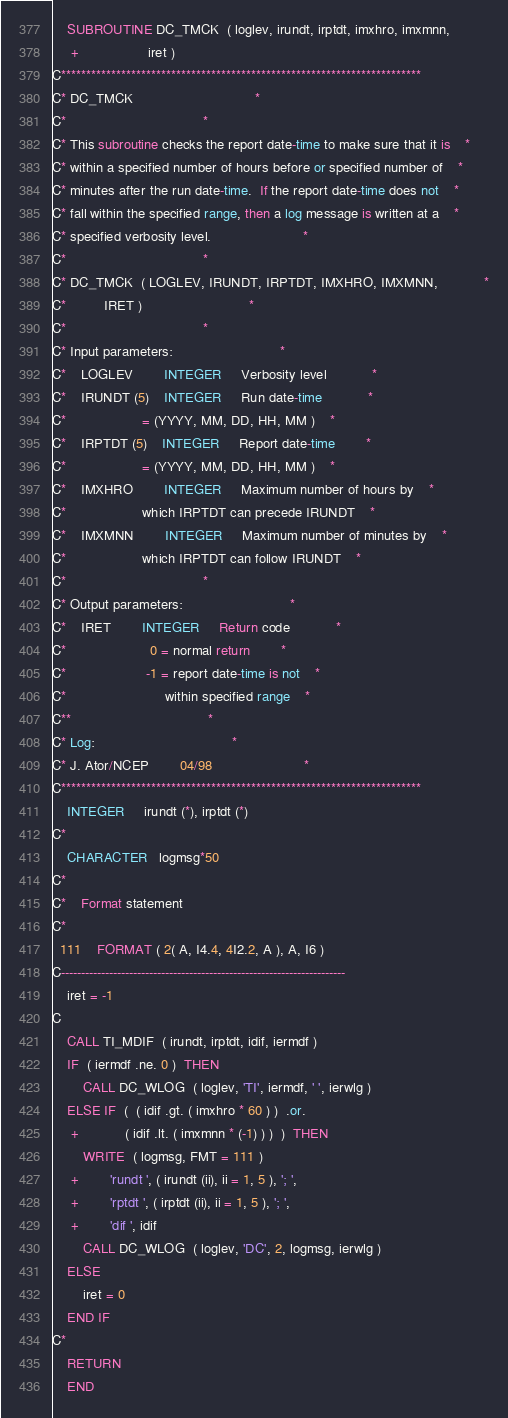Convert code to text. <code><loc_0><loc_0><loc_500><loc_500><_FORTRAN_>	SUBROUTINE DC_TMCK  ( loglev, irundt, irptdt, imxhro, imxmnn,
     +			      iret )
C************************************************************************
C* DC_TMCK								*
C*									*
C* This subroutine checks the report date-time to make sure that it is	*
C* within a specified number of hours before or specified number of	*
C* minutes after the run date-time.  If the report date-time does not	*
C* fall within the specified range, then a log message is written at a	*
C* specified verbosity level.						*
C*									*
C* DC_TMCK  ( LOGLEV, IRUNDT, IRPTDT, IMXHRO, IMXMNN,			*
C*	      IRET )							*
C*									*
C* Input parameters:							*
C*	LOGLEV		INTEGER		Verbosity level			*
C*	IRUNDT (5)	INTEGER		Run date-time 			*
C*					= (YYYY, MM, DD, HH, MM ) 	*
C*	IRPTDT (5)	INTEGER		Report date-time 		*
C*					= (YYYY, MM, DD, HH, MM ) 	*
C*	IMXHRO		INTEGER		Maximum number of hours by	*
C*					which IRPTDT can precede IRUNDT	*
C*	IMXMNN		INTEGER		Maximum number of minutes by	*
C*					which IRPTDT can follow IRUNDT	*
C*									*
C* Output parameters:							*
C*	IRET		INTEGER		Return code 			*
C*					  0 = normal return 		*
C*					 -1 = report date-time is not	*
C*					      within specified range 	*
C**									*
C* Log:									*
C* J. Ator/NCEP		04/98						*
C************************************************************************
	INTEGER		irundt (*), irptdt (*)
C*
	CHARACTER	logmsg*50
C*
C*	Format statement
C*
  111	FORMAT ( 2( A, I4.4, 4I2.2, A ), A, I6 )
C-----------------------------------------------------------------------
	iret = -1
C
	CALL TI_MDIF  ( irundt, irptdt, idif, iermdf )
	IF  ( iermdf .ne. 0 )  THEN
	    CALL DC_WLOG  ( loglev, 'TI', iermdf, ' ', ierwlg )
	ELSE IF  (  ( idif .gt. ( imxhro * 60 ) )  .or.
     +		    ( idif .lt. ( imxmnn * (-1) ) )  )  THEN
	    WRITE  ( logmsg, FMT = 111 )
     +		'rundt ', ( irundt (ii), ii = 1, 5 ), '; ',
     +		'rptdt ', ( irptdt (ii), ii = 1, 5 ), '; ',
     +		'dif ', idif
	    CALL DC_WLOG  ( loglev, 'DC', 2, logmsg, ierwlg )
	ELSE
	    iret = 0
	END IF
C*
	RETURN
	END
</code> 